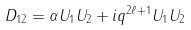<formula> <loc_0><loc_0><loc_500><loc_500>D _ { 1 2 } = \alpha U _ { 1 } U _ { 2 } + i q ^ { 2 \ell + 1 } U _ { 1 } U _ { 2 }</formula> 